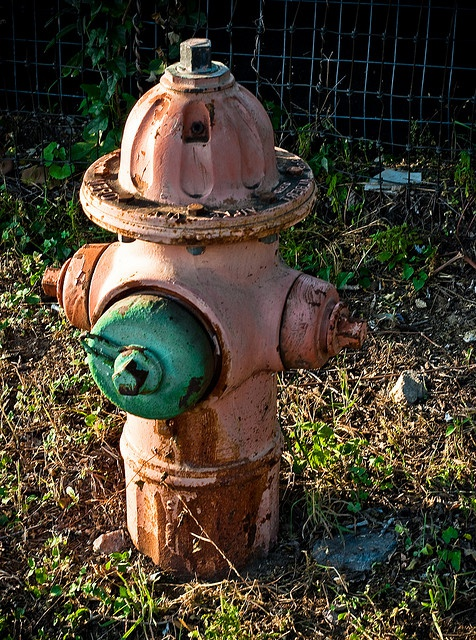Describe the objects in this image and their specific colors. I can see a fire hydrant in black, brown, maroon, and gray tones in this image. 